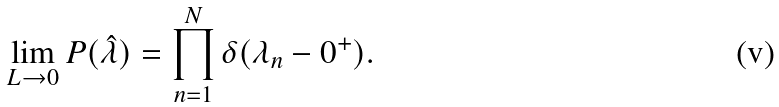Convert formula to latex. <formula><loc_0><loc_0><loc_500><loc_500>\lim _ { L \to 0 } P ( \hat { \lambda } ) = \prod _ { n = 1 } ^ { N } \delta ( \lambda _ { n } - 0 ^ { + } ) .</formula> 